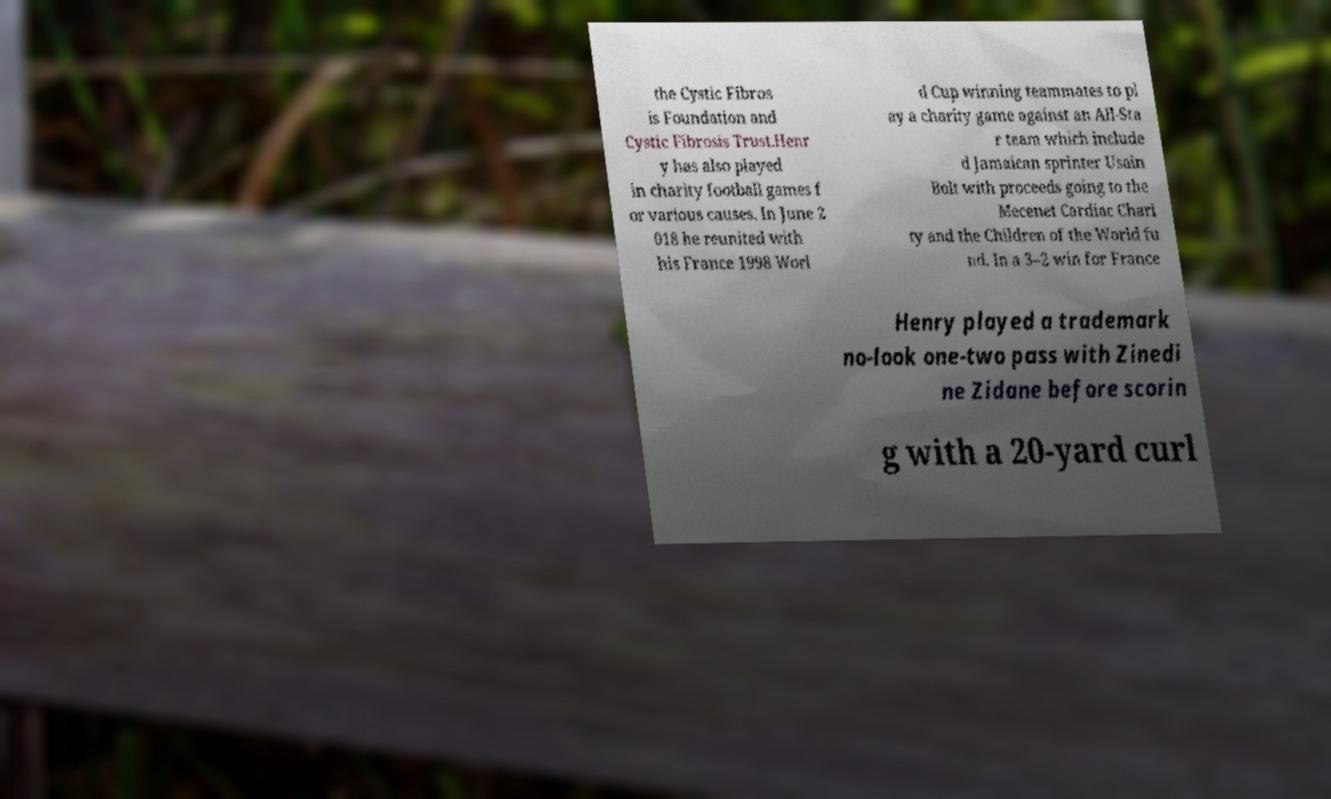Could you assist in decoding the text presented in this image and type it out clearly? the Cystic Fibros is Foundation and Cystic Fibrosis Trust.Henr y has also played in charity football games f or various causes. In June 2 018 he reunited with his France 1998 Worl d Cup winning teammates to pl ay a charity game against an All-Sta r team which include d Jamaican sprinter Usain Bolt with proceeds going to the Mecenet Cardiac Chari ty and the Children of the World fu nd. In a 3–2 win for France Henry played a trademark no-look one-two pass with Zinedi ne Zidane before scorin g with a 20-yard curl 